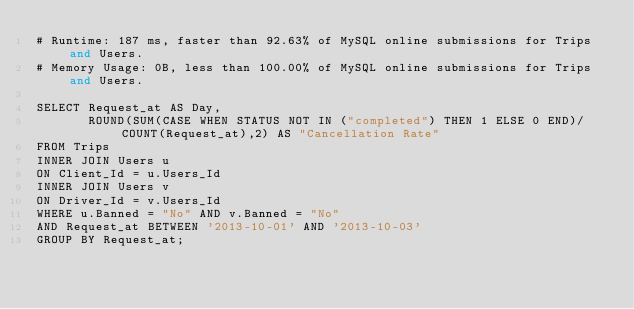<code> <loc_0><loc_0><loc_500><loc_500><_SQL_># Runtime: 187 ms, faster than 92.63% of MySQL online submissions for Trips and Users.
# Memory Usage: 0B, less than 100.00% of MySQL online submissions for Trips and Users.

SELECT Request_at AS Day,
       ROUND(SUM(CASE WHEN STATUS NOT IN ("completed") THEN 1 ELSE 0 END)/COUNT(Request_at),2) AS "Cancellation Rate"
FROM Trips
INNER JOIN Users u
ON Client_Id = u.Users_Id
INNER JOIN Users v
ON Driver_Id = v.Users_Id
WHERE u.Banned = "No" AND v.Banned = "No"
AND Request_at BETWEEN '2013-10-01' AND '2013-10-03'
GROUP BY Request_at;
</code> 